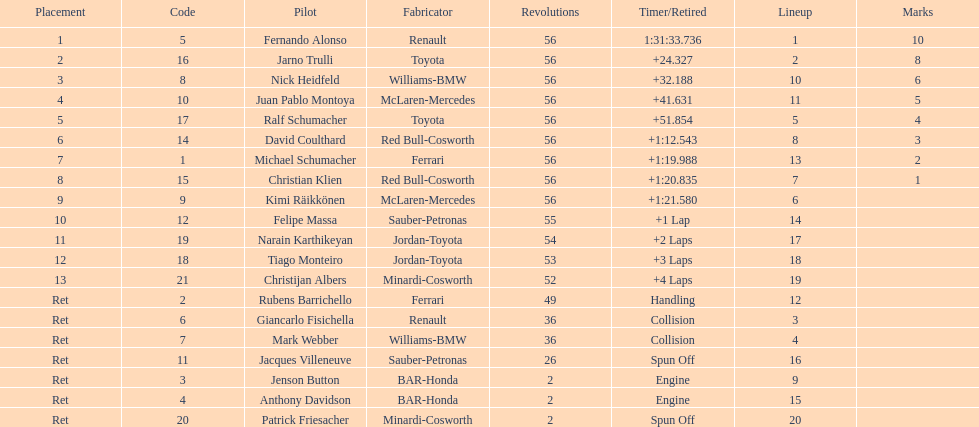How many drivers ended the race early because of engine problems? 2. 